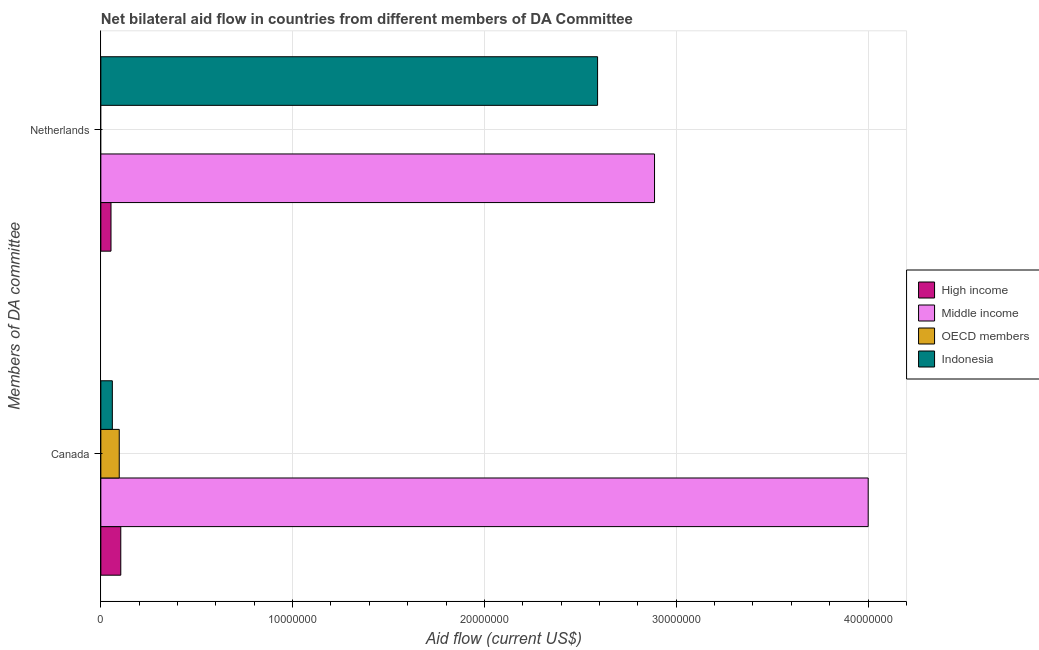How many different coloured bars are there?
Ensure brevity in your answer.  4. Are the number of bars on each tick of the Y-axis equal?
Ensure brevity in your answer.  No. How many bars are there on the 2nd tick from the bottom?
Keep it short and to the point. 3. What is the amount of aid given by canada in Middle income?
Offer a very short reply. 4.00e+07. Across all countries, what is the maximum amount of aid given by netherlands?
Provide a short and direct response. 2.89e+07. Across all countries, what is the minimum amount of aid given by canada?
Offer a very short reply. 6.00e+05. In which country was the amount of aid given by netherlands maximum?
Your response must be concise. Middle income. What is the total amount of aid given by netherlands in the graph?
Provide a succinct answer. 5.53e+07. What is the difference between the amount of aid given by canada in OECD members and that in Middle income?
Provide a short and direct response. -3.90e+07. What is the difference between the amount of aid given by canada in Indonesia and the amount of aid given by netherlands in High income?
Your answer should be very brief. 7.00e+04. What is the average amount of aid given by netherlands per country?
Keep it short and to the point. 1.38e+07. What is the difference between the amount of aid given by netherlands and amount of aid given by canada in High income?
Give a very brief answer. -5.10e+05. In how many countries, is the amount of aid given by netherlands greater than 18000000 US$?
Provide a succinct answer. 2. What is the ratio of the amount of aid given by canada in Indonesia to that in OECD members?
Provide a succinct answer. 0.62. Is the amount of aid given by netherlands in Middle income less than that in Indonesia?
Your answer should be compact. No. How many bars are there?
Offer a very short reply. 7. How many countries are there in the graph?
Provide a succinct answer. 4. Are the values on the major ticks of X-axis written in scientific E-notation?
Your answer should be compact. No. Does the graph contain any zero values?
Keep it short and to the point. Yes. Where does the legend appear in the graph?
Offer a terse response. Center right. How many legend labels are there?
Your answer should be compact. 4. What is the title of the graph?
Give a very brief answer. Net bilateral aid flow in countries from different members of DA Committee. Does "South Asia" appear as one of the legend labels in the graph?
Your response must be concise. No. What is the label or title of the Y-axis?
Make the answer very short. Members of DA committee. What is the Aid flow (current US$) of High income in Canada?
Offer a terse response. 1.04e+06. What is the Aid flow (current US$) in Middle income in Canada?
Offer a terse response. 4.00e+07. What is the Aid flow (current US$) of OECD members in Canada?
Ensure brevity in your answer.  9.60e+05. What is the Aid flow (current US$) of High income in Netherlands?
Provide a succinct answer. 5.30e+05. What is the Aid flow (current US$) in Middle income in Netherlands?
Your answer should be compact. 2.89e+07. What is the Aid flow (current US$) of Indonesia in Netherlands?
Offer a very short reply. 2.59e+07. Across all Members of DA committee, what is the maximum Aid flow (current US$) in High income?
Make the answer very short. 1.04e+06. Across all Members of DA committee, what is the maximum Aid flow (current US$) in Middle income?
Provide a succinct answer. 4.00e+07. Across all Members of DA committee, what is the maximum Aid flow (current US$) of OECD members?
Your answer should be compact. 9.60e+05. Across all Members of DA committee, what is the maximum Aid flow (current US$) in Indonesia?
Keep it short and to the point. 2.59e+07. Across all Members of DA committee, what is the minimum Aid flow (current US$) in High income?
Offer a very short reply. 5.30e+05. Across all Members of DA committee, what is the minimum Aid flow (current US$) in Middle income?
Ensure brevity in your answer.  2.89e+07. Across all Members of DA committee, what is the minimum Aid flow (current US$) in OECD members?
Make the answer very short. 0. What is the total Aid flow (current US$) in High income in the graph?
Give a very brief answer. 1.57e+06. What is the total Aid flow (current US$) in Middle income in the graph?
Make the answer very short. 6.89e+07. What is the total Aid flow (current US$) of OECD members in the graph?
Ensure brevity in your answer.  9.60e+05. What is the total Aid flow (current US$) of Indonesia in the graph?
Offer a terse response. 2.65e+07. What is the difference between the Aid flow (current US$) in High income in Canada and that in Netherlands?
Give a very brief answer. 5.10e+05. What is the difference between the Aid flow (current US$) of Middle income in Canada and that in Netherlands?
Give a very brief answer. 1.11e+07. What is the difference between the Aid flow (current US$) in Indonesia in Canada and that in Netherlands?
Provide a short and direct response. -2.53e+07. What is the difference between the Aid flow (current US$) of High income in Canada and the Aid flow (current US$) of Middle income in Netherlands?
Keep it short and to the point. -2.78e+07. What is the difference between the Aid flow (current US$) in High income in Canada and the Aid flow (current US$) in Indonesia in Netherlands?
Offer a terse response. -2.49e+07. What is the difference between the Aid flow (current US$) of Middle income in Canada and the Aid flow (current US$) of Indonesia in Netherlands?
Give a very brief answer. 1.41e+07. What is the difference between the Aid flow (current US$) in OECD members in Canada and the Aid flow (current US$) in Indonesia in Netherlands?
Ensure brevity in your answer.  -2.49e+07. What is the average Aid flow (current US$) of High income per Members of DA committee?
Ensure brevity in your answer.  7.85e+05. What is the average Aid flow (current US$) of Middle income per Members of DA committee?
Give a very brief answer. 3.44e+07. What is the average Aid flow (current US$) in OECD members per Members of DA committee?
Provide a succinct answer. 4.80e+05. What is the average Aid flow (current US$) of Indonesia per Members of DA committee?
Offer a very short reply. 1.32e+07. What is the difference between the Aid flow (current US$) of High income and Aid flow (current US$) of Middle income in Canada?
Offer a very short reply. -3.90e+07. What is the difference between the Aid flow (current US$) in Middle income and Aid flow (current US$) in OECD members in Canada?
Ensure brevity in your answer.  3.90e+07. What is the difference between the Aid flow (current US$) in Middle income and Aid flow (current US$) in Indonesia in Canada?
Provide a succinct answer. 3.94e+07. What is the difference between the Aid flow (current US$) in OECD members and Aid flow (current US$) in Indonesia in Canada?
Your response must be concise. 3.60e+05. What is the difference between the Aid flow (current US$) of High income and Aid flow (current US$) of Middle income in Netherlands?
Offer a terse response. -2.83e+07. What is the difference between the Aid flow (current US$) of High income and Aid flow (current US$) of Indonesia in Netherlands?
Provide a succinct answer. -2.54e+07. What is the difference between the Aid flow (current US$) in Middle income and Aid flow (current US$) in Indonesia in Netherlands?
Ensure brevity in your answer.  2.97e+06. What is the ratio of the Aid flow (current US$) in High income in Canada to that in Netherlands?
Your answer should be compact. 1.96. What is the ratio of the Aid flow (current US$) in Middle income in Canada to that in Netherlands?
Your answer should be very brief. 1.39. What is the ratio of the Aid flow (current US$) in Indonesia in Canada to that in Netherlands?
Offer a very short reply. 0.02. What is the difference between the highest and the second highest Aid flow (current US$) in High income?
Your answer should be compact. 5.10e+05. What is the difference between the highest and the second highest Aid flow (current US$) of Middle income?
Your response must be concise. 1.11e+07. What is the difference between the highest and the second highest Aid flow (current US$) of Indonesia?
Provide a short and direct response. 2.53e+07. What is the difference between the highest and the lowest Aid flow (current US$) in High income?
Your response must be concise. 5.10e+05. What is the difference between the highest and the lowest Aid flow (current US$) of Middle income?
Give a very brief answer. 1.11e+07. What is the difference between the highest and the lowest Aid flow (current US$) of OECD members?
Offer a very short reply. 9.60e+05. What is the difference between the highest and the lowest Aid flow (current US$) of Indonesia?
Keep it short and to the point. 2.53e+07. 